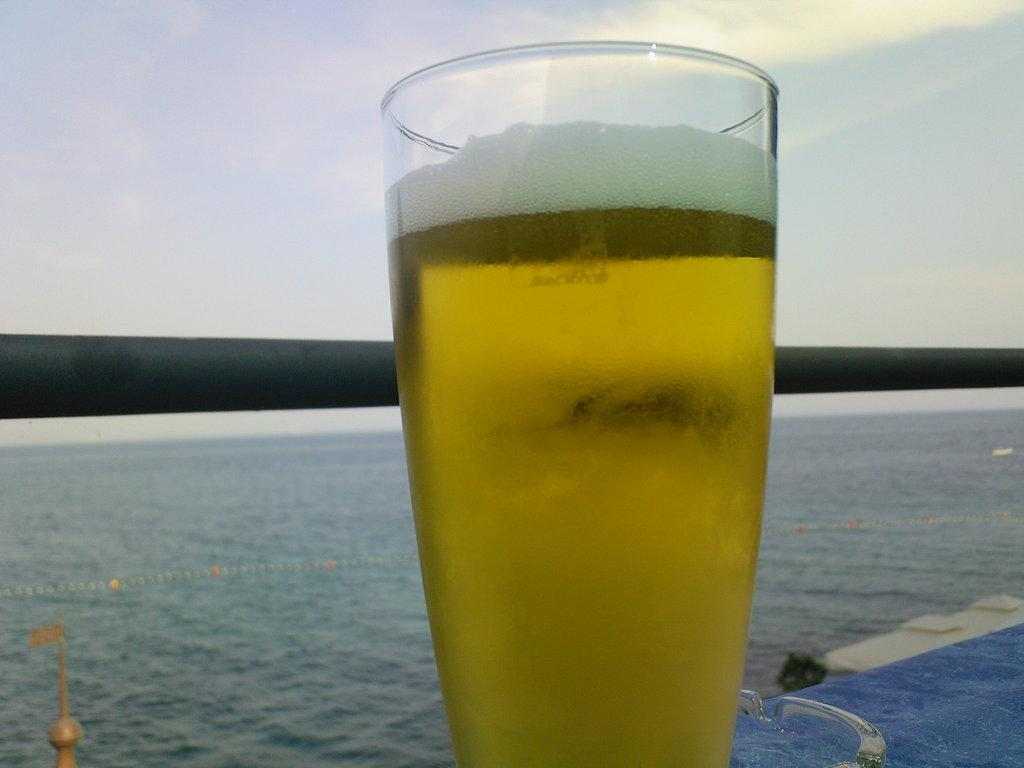What is in the glass that is visible in the image? There is a glass of drink in the image. What other object can be seen in the image besides the glass? There is a metal rod visible in the image. What can be seen in the background of the image? Water is visible in the background of the image. What is visible at the top of the image? The sky is visible at the top of the image. Can you tell me how many yams are being used to start a fire in the image? There are no yams or fires present in the image; it features a glass of drink, a metal rod, water in the background, and the sky. How many feet are visible in the image? There are no feet visible in the image. 